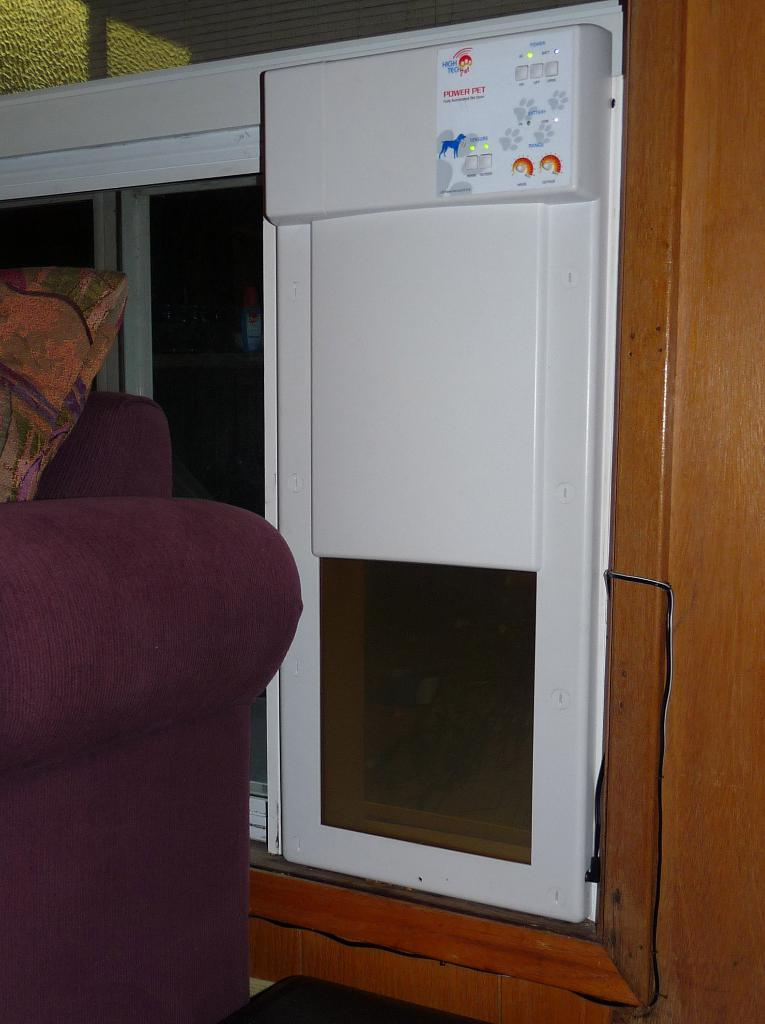Provide a one-sentence caption for the provided image. The Power Pet machine seems to be embedded into the wall. 